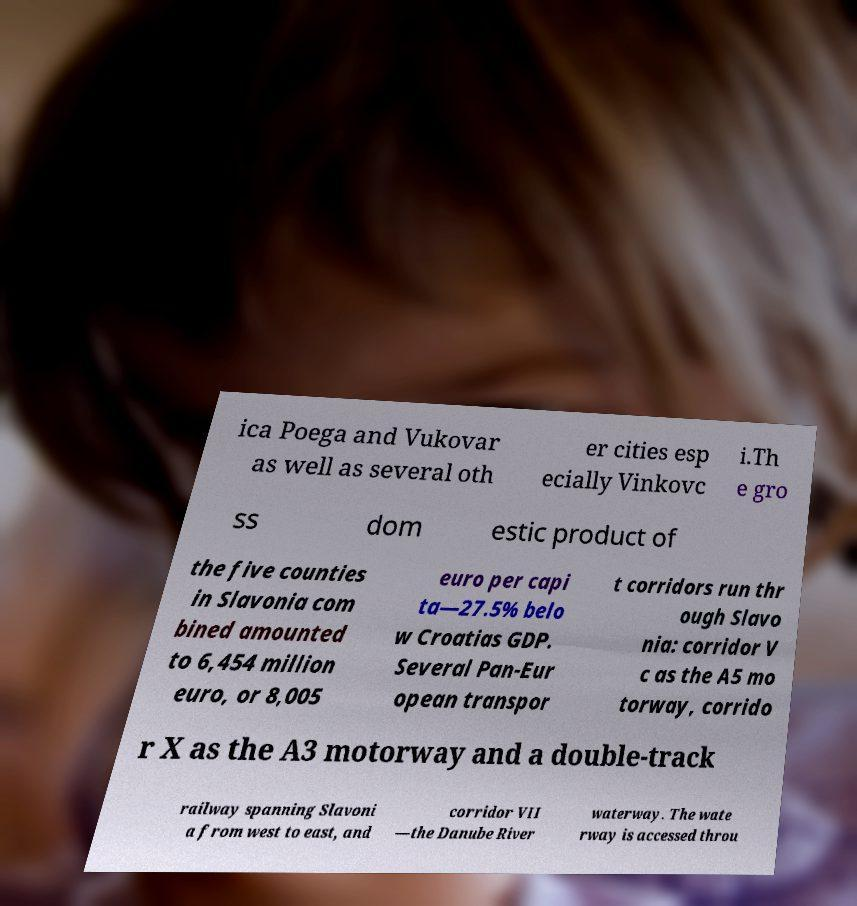Can you accurately transcribe the text from the provided image for me? ica Poega and Vukovar as well as several oth er cities esp ecially Vinkovc i.Th e gro ss dom estic product of the five counties in Slavonia com bined amounted to 6,454 million euro, or 8,005 euro per capi ta—27.5% belo w Croatias GDP. Several Pan-Eur opean transpor t corridors run thr ough Slavo nia: corridor V c as the A5 mo torway, corrido r X as the A3 motorway and a double-track railway spanning Slavoni a from west to east, and corridor VII —the Danube River waterway. The wate rway is accessed throu 